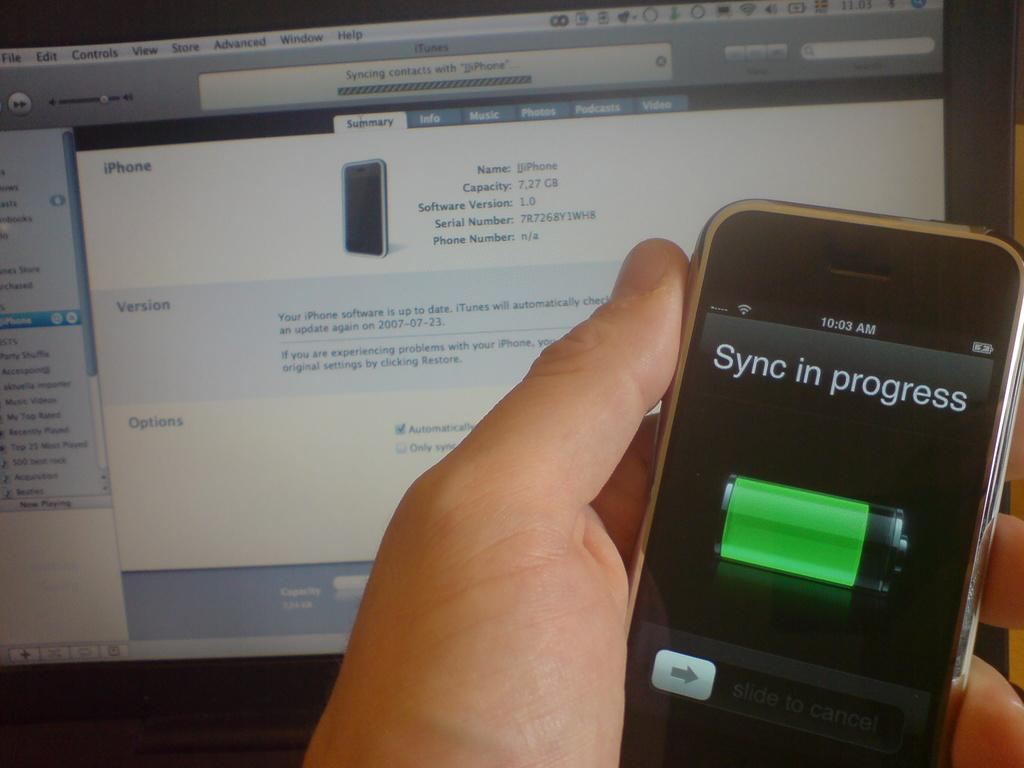<image>
Create a compact narrative representing the image presented. Sync in progress on a cellphone with Itunes page on pc screen in background 